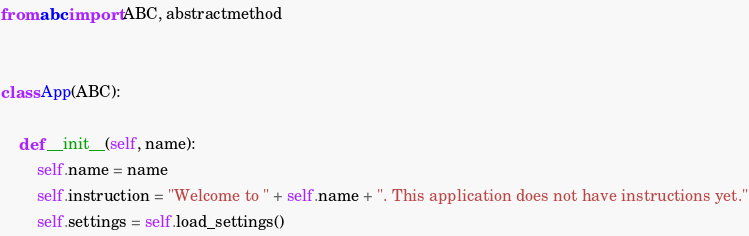Convert code to text. <code><loc_0><loc_0><loc_500><loc_500><_Python_>
from abc import ABC, abstractmethod


class App(ABC):

    def __init__(self, name):
        self.name = name
        self.instruction = "Welcome to " + self.name + ". This application does not have instructions yet."
        self.settings = self.load_settings()
</code> 